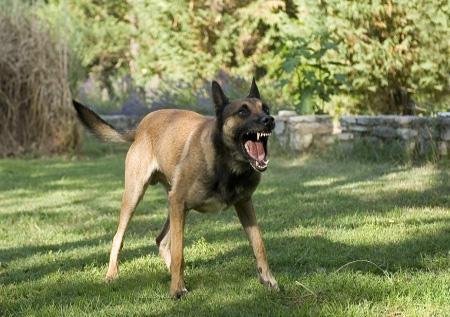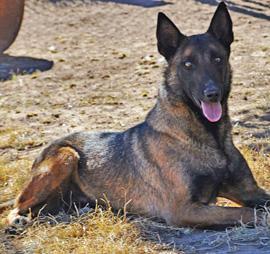The first image is the image on the left, the second image is the image on the right. Given the left and right images, does the statement "At least one dog has a leash attached, and at least one dog has an open, non-snarling mouth." hold true? Answer yes or no. No. The first image is the image on the left, the second image is the image on the right. Examine the images to the left and right. Is the description "One of the dogs is sitting down & looking towards the camera." accurate? Answer yes or no. Yes. 